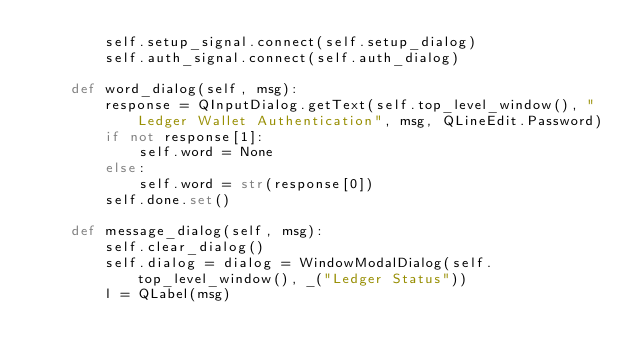Convert code to text. <code><loc_0><loc_0><loc_500><loc_500><_Python_>        self.setup_signal.connect(self.setup_dialog)
        self.auth_signal.connect(self.auth_dialog)

    def word_dialog(self, msg):
        response = QInputDialog.getText(self.top_level_window(), "Ledger Wallet Authentication", msg, QLineEdit.Password)
        if not response[1]:
            self.word = None
        else:
            self.word = str(response[0])
        self.done.set()
    
    def message_dialog(self, msg):
        self.clear_dialog()
        self.dialog = dialog = WindowModalDialog(self.top_level_window(), _("Ledger Status"))
        l = QLabel(msg)</code> 